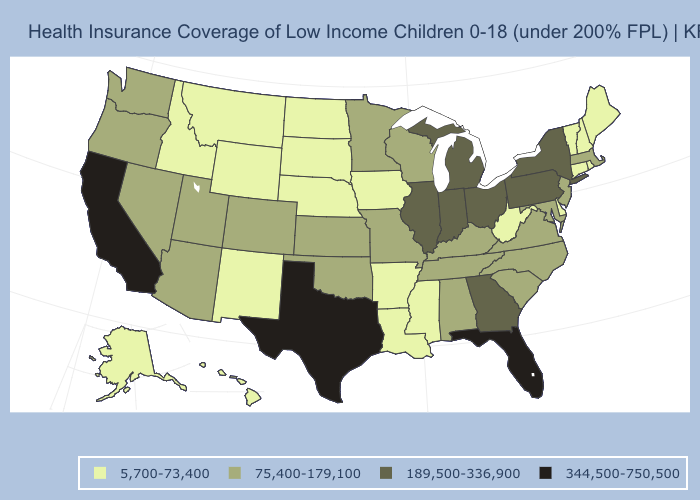What is the lowest value in the West?
Be succinct. 5,700-73,400. Which states have the lowest value in the USA?
Answer briefly. Alaska, Arkansas, Connecticut, Delaware, Hawaii, Idaho, Iowa, Louisiana, Maine, Mississippi, Montana, Nebraska, New Hampshire, New Mexico, North Dakota, Rhode Island, South Dakota, Vermont, West Virginia, Wyoming. What is the value of Wisconsin?
Answer briefly. 75,400-179,100. Name the states that have a value in the range 75,400-179,100?
Be succinct. Alabama, Arizona, Colorado, Kansas, Kentucky, Maryland, Massachusetts, Minnesota, Missouri, Nevada, New Jersey, North Carolina, Oklahoma, Oregon, South Carolina, Tennessee, Utah, Virginia, Washington, Wisconsin. Does Vermont have the same value as North Carolina?
Concise answer only. No. Name the states that have a value in the range 189,500-336,900?
Give a very brief answer. Georgia, Illinois, Indiana, Michigan, New York, Ohio, Pennsylvania. Name the states that have a value in the range 189,500-336,900?
Write a very short answer. Georgia, Illinois, Indiana, Michigan, New York, Ohio, Pennsylvania. What is the value of Kentucky?
Concise answer only. 75,400-179,100. Name the states that have a value in the range 5,700-73,400?
Concise answer only. Alaska, Arkansas, Connecticut, Delaware, Hawaii, Idaho, Iowa, Louisiana, Maine, Mississippi, Montana, Nebraska, New Hampshire, New Mexico, North Dakota, Rhode Island, South Dakota, Vermont, West Virginia, Wyoming. Does Georgia have a lower value than Arkansas?
Be succinct. No. Does Nevada have the lowest value in the West?
Write a very short answer. No. Name the states that have a value in the range 75,400-179,100?
Keep it brief. Alabama, Arizona, Colorado, Kansas, Kentucky, Maryland, Massachusetts, Minnesota, Missouri, Nevada, New Jersey, North Carolina, Oklahoma, Oregon, South Carolina, Tennessee, Utah, Virginia, Washington, Wisconsin. Which states have the highest value in the USA?
Short answer required. California, Florida, Texas. What is the value of Wisconsin?
Concise answer only. 75,400-179,100. Which states hav the highest value in the MidWest?
Be succinct. Illinois, Indiana, Michigan, Ohio. 